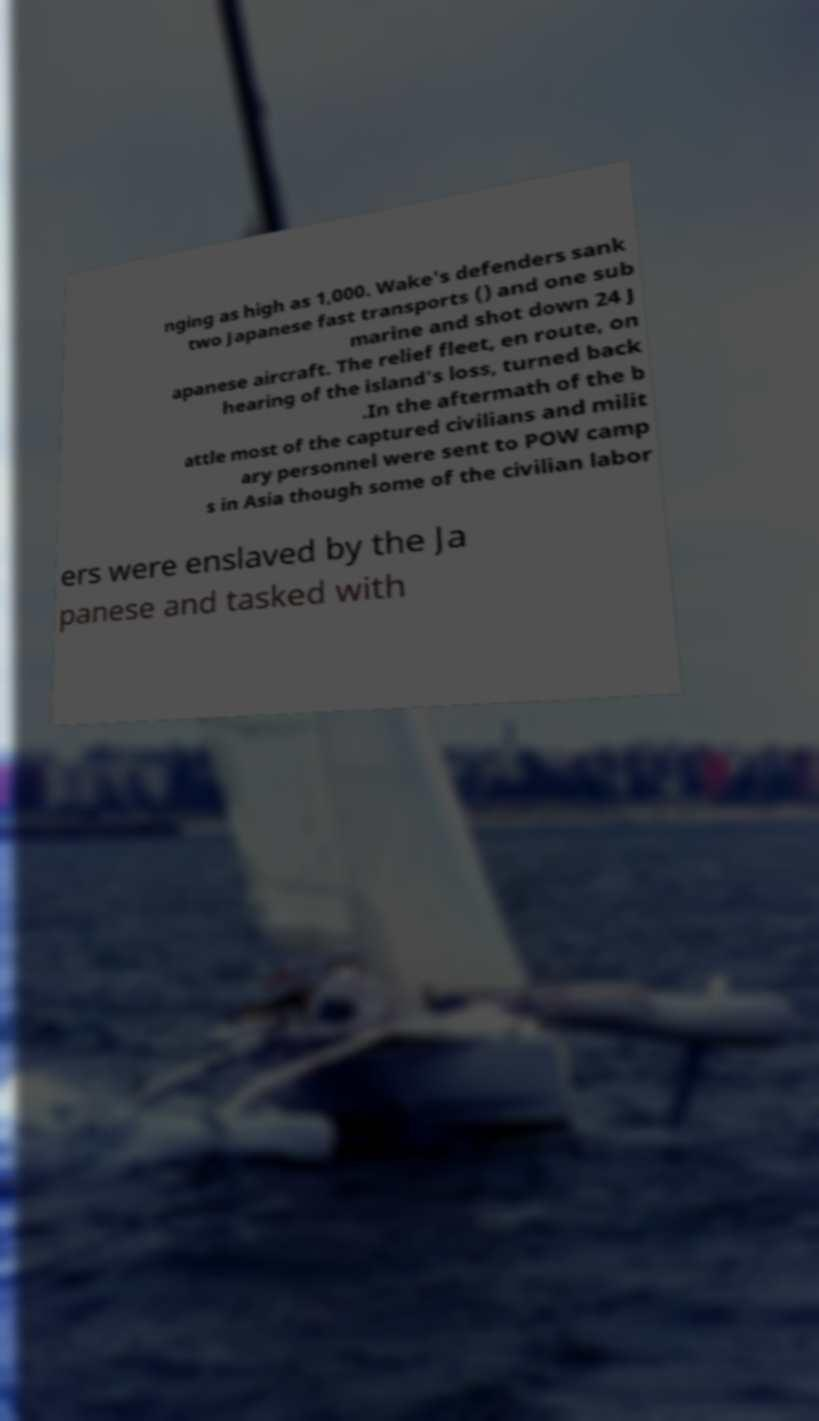There's text embedded in this image that I need extracted. Can you transcribe it verbatim? nging as high as 1,000. Wake's defenders sank two Japanese fast transports () and one sub marine and shot down 24 J apanese aircraft. The relief fleet, en route, on hearing of the island's loss, turned back .In the aftermath of the b attle most of the captured civilians and milit ary personnel were sent to POW camp s in Asia though some of the civilian labor ers were enslaved by the Ja panese and tasked with 